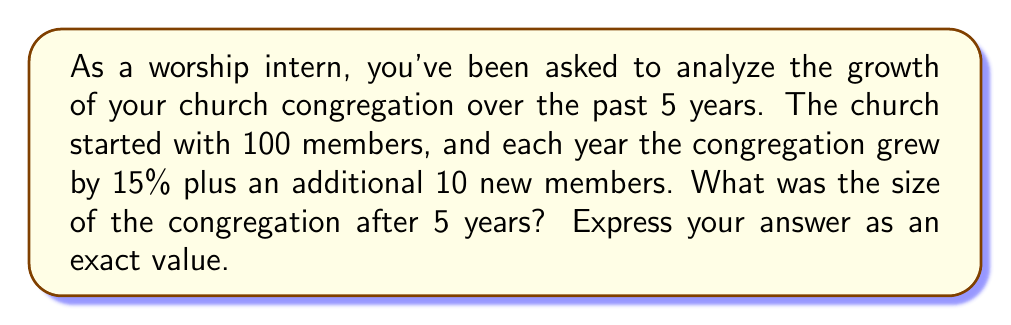Could you help me with this problem? Let's approach this step-by-step:

1) Let $a_n$ represent the number of congregation members after $n$ years.

2) We're given that $a_0 = 100$ (initial size).

3) Each year, the congregation grows by 15% of its current size, plus 10 new members. We can represent this as:

   $a_{n+1} = 1.15a_n + 10$

4) This is a non-homogeneous first-order linear recurrence relation. To solve it, we can use the method of generating functions or iterate the relation:

   $a_1 = 1.15(100) + 10 = 125$
   $a_2 = 1.15(125) + 10 = 153.75$
   $a_3 = 1.15(153.75) + 10 = 186.8125$
   $a_4 = 1.15(186.8125) + 10 = 224.834375$
   $a_5 = 1.15(224.834375) + 10 = 268.5595312...$

5) The general solution to this recurrence relation is:

   $a_n = 100(1.15)^n + \frac{10}{0.15}[(1.15)^n - 1]$

6) Substituting $n = 5$:

   $a_5 = 100(1.15)^5 + \frac{10}{0.15}[(1.15)^5 - 1]$

7) Simplifying:

   $a_5 = 100(2.0113689) + 66.666667[(2.0113689) - 1]$
   $a_5 = 201.13689 + 67.424593$
   $a_5 = 268.561483$
Answer: The size of the congregation after 5 years is $\frac{268561483}{1000000} = \frac{201136890 + 67424593}{1000000}$ members. 